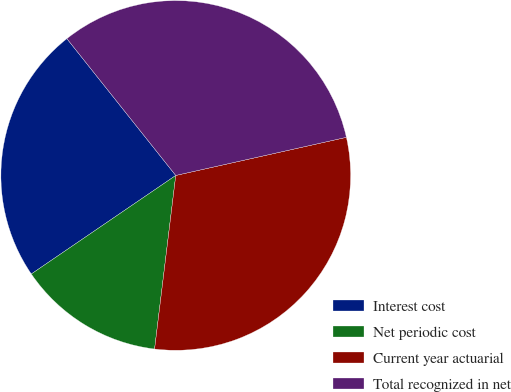<chart> <loc_0><loc_0><loc_500><loc_500><pie_chart><fcel>Interest cost<fcel>Net periodic cost<fcel>Current year actuarial<fcel>Total recognized in net<nl><fcel>23.83%<fcel>13.54%<fcel>30.43%<fcel>32.2%<nl></chart> 